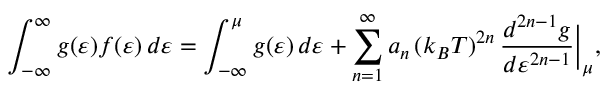<formula> <loc_0><loc_0><loc_500><loc_500>\int _ { - \infty } ^ { \infty } g ( \varepsilon ) f ( \varepsilon ) \, d \varepsilon = \int _ { - \infty } ^ { \mu } g ( \varepsilon ) \, d \varepsilon + \sum _ { n = 1 } ^ { \infty } a _ { n } \, ( k _ { B } T ) ^ { 2 n } \, \frac { d ^ { 2 n - 1 } g } { d \varepsilon ^ { 2 n - 1 } } \Big | _ { \mu } ,</formula> 